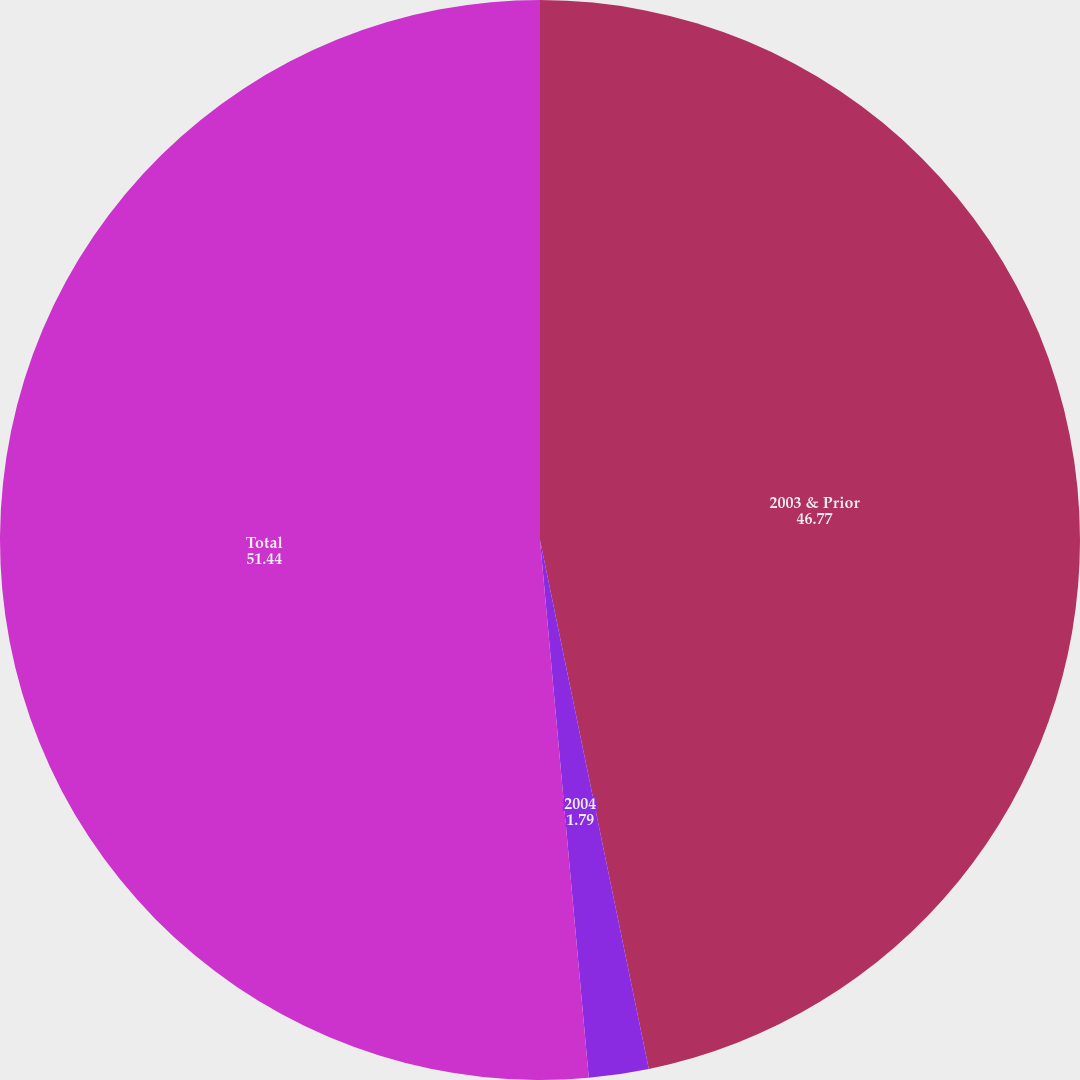Convert chart to OTSL. <chart><loc_0><loc_0><loc_500><loc_500><pie_chart><fcel>2003 & Prior<fcel>2004<fcel>Total<nl><fcel>46.77%<fcel>1.79%<fcel>51.44%<nl></chart> 